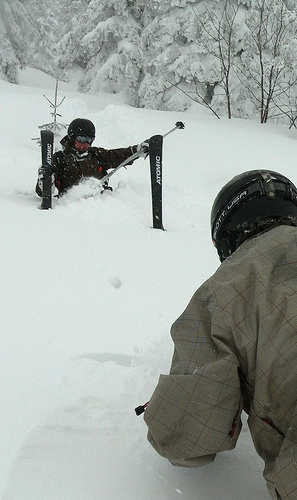Describe the objects in this image and their specific colors. I can see people in darkgray, gray, and black tones, people in darkgray, black, gray, and lightgray tones, and skis in darkgray, black, lightgray, and gray tones in this image. 